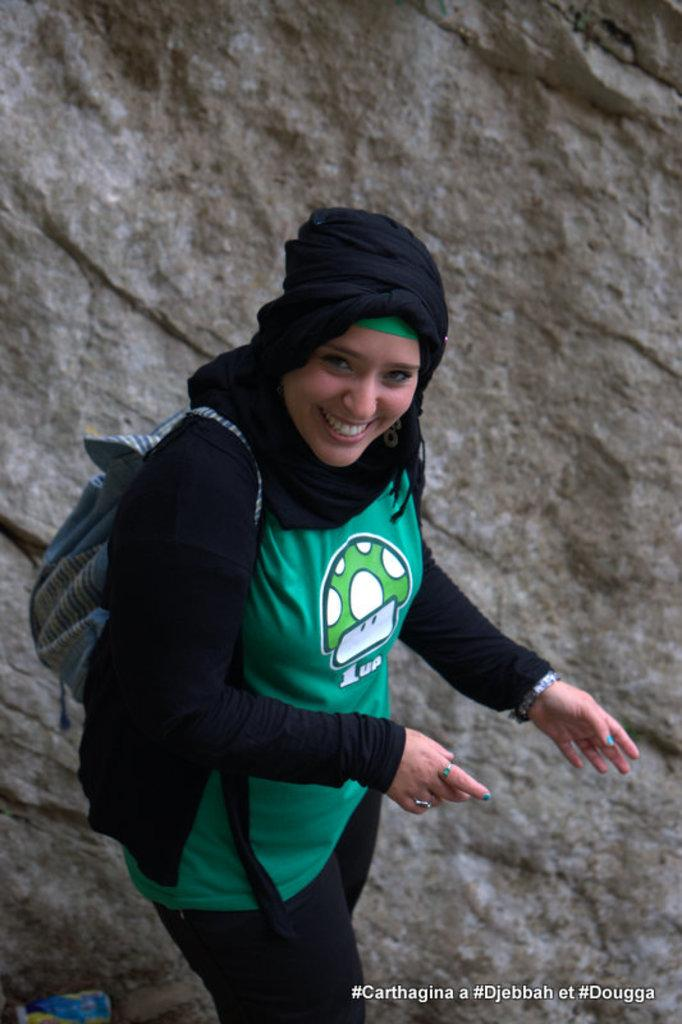What is the main subject in the foreground of the image? There is a woman in the foreground of the image. What is the woman wearing? The woman is wearing a black and green dress and a backpack. What is covering the woman's head? The woman has a scarf over her head. What can be seen in the background of the image? There is a rock in the background of the image. What type of paint is the woman using on the rock in the image? There is no paint or painting activity depicted in the image. The woman is not interacting with the rock in any way. 